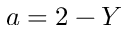Convert formula to latex. <formula><loc_0><loc_0><loc_500><loc_500>a = 2 - Y</formula> 